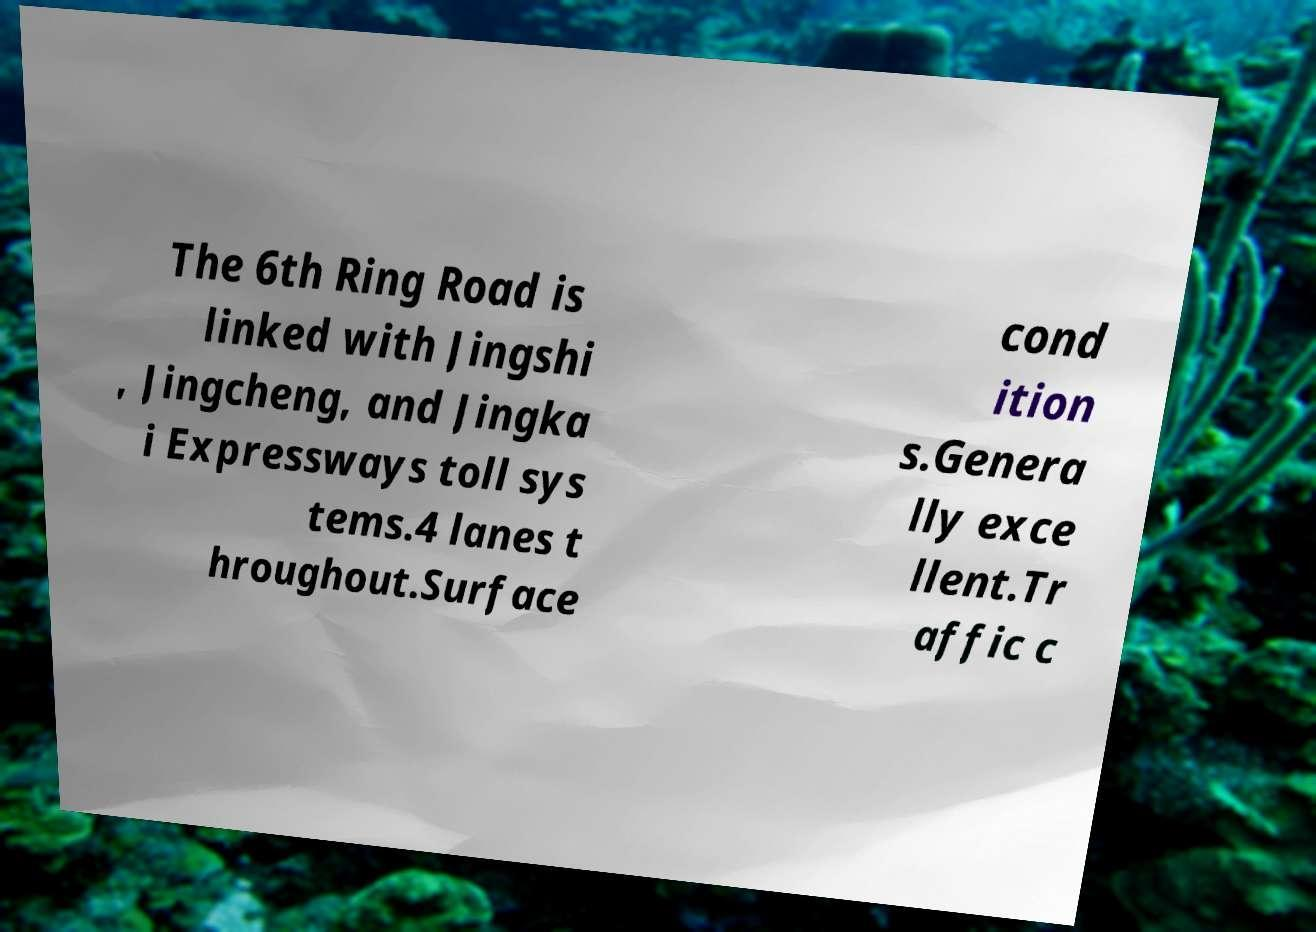I need the written content from this picture converted into text. Can you do that? The 6th Ring Road is linked with Jingshi , Jingcheng, and Jingka i Expressways toll sys tems.4 lanes t hroughout.Surface cond ition s.Genera lly exce llent.Tr affic c 